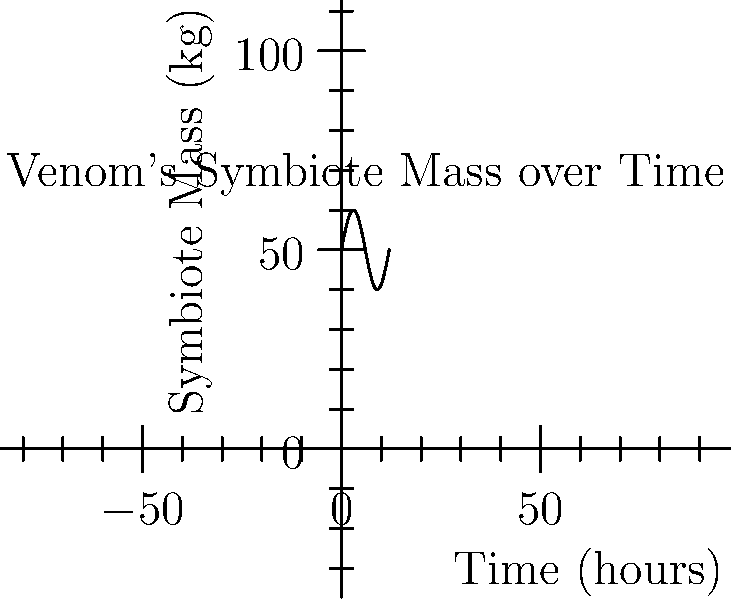The graph shows the mass of Venom's symbiote over a 12-hour period. If the mass $m$ (in kg) at time $t$ (in hours) is given by the function $m(t) = 50 + 10\sin(\frac{\pi t}{6})$, at what time(s) in the 12-hour period is the rate of change of the symbiote's mass equal to zero? To find when the rate of change is zero, we need to follow these steps:

1) The rate of change is given by the derivative of the mass function. Let's calculate $\frac{dm}{dt}$:

   $$\frac{dm}{dt} = \frac{d}{dt}[50 + 10\sin(\frac{\pi t}{6})] = 10 \cdot \frac{\pi}{6} \cos(\frac{\pi t}{6})$$

2) The rate of change is zero when $\frac{dm}{dt} = 0$:

   $$10 \cdot \frac{\pi}{6} \cos(\frac{\pi t}{6}) = 0$$

3) This equation is true when $\cos(\frac{\pi t}{6}) = 0$, which occurs when $\frac{\pi t}{6} = \frac{\pi}{2}$ or $\frac{3\pi}{2}$

4) Solving for $t$:
   
   For $\frac{\pi t}{6} = \frac{\pi}{2}$: $t = 3$
   For $\frac{\pi t}{6} = \frac{3\pi}{2}$: $t = 9$

5) Therefore, the rate of change is zero at $t = 3$ and $t = 9$ hours.
Answer: 3 hours and 9 hours 